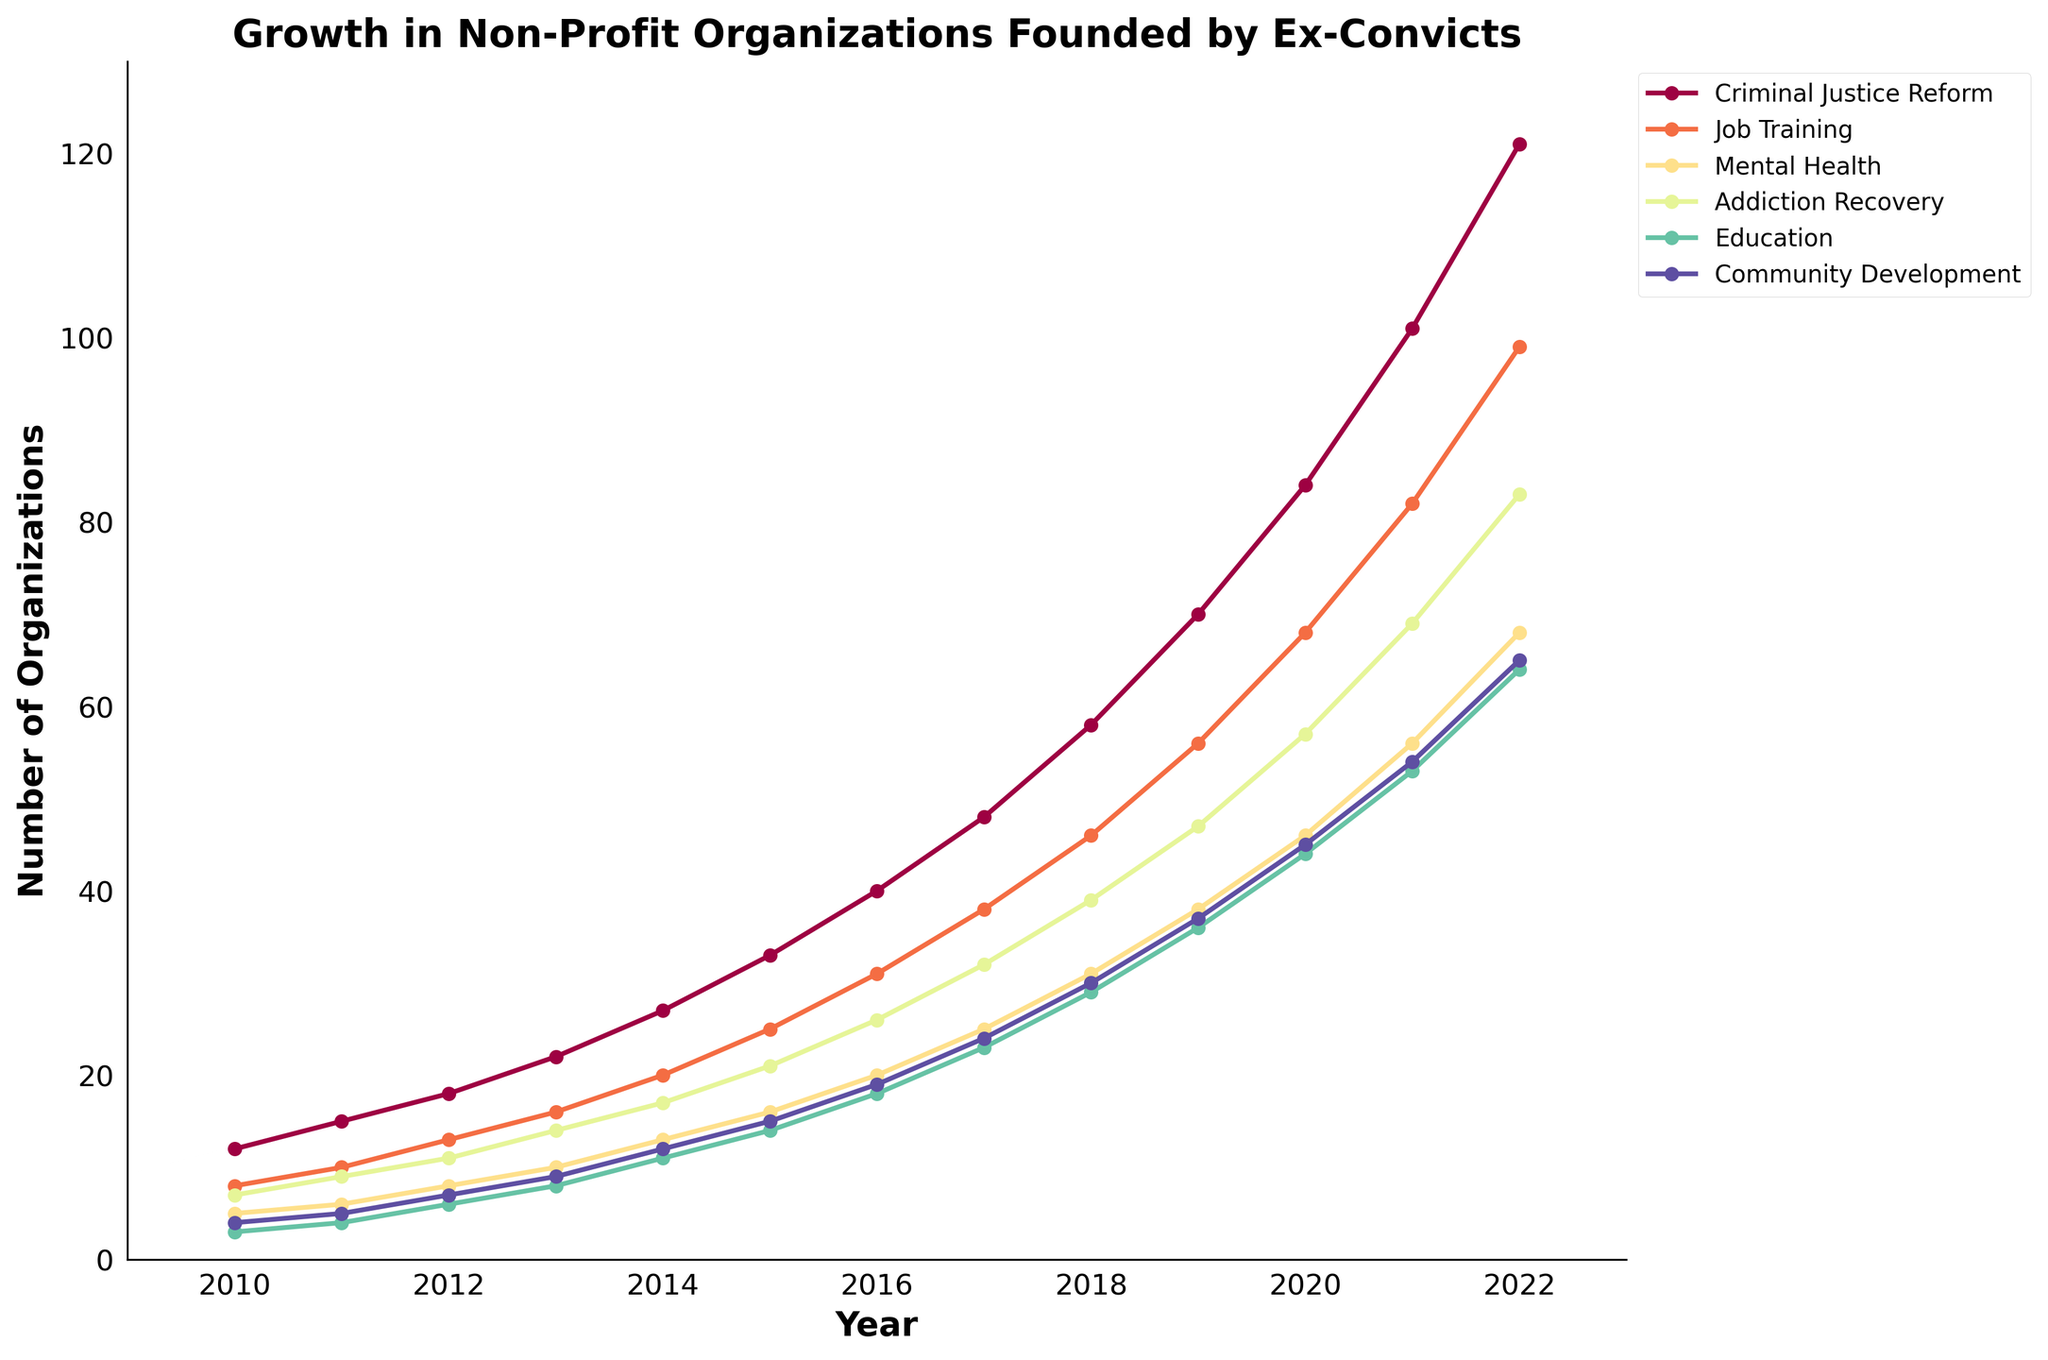Which organization focus area had the highest growth from 2010 to 2022? To determine this, examine the endpoints of each line in the chart. The line for 'Criminal Justice Reform' starts at 12 in 2010 and ends at 121 in 2022, which is the highest among all focus areas.
Answer: Criminal Justice Reform How many organizations in total were there for the three largest categories in 2022? Add the number of organizations for 'Criminal Justice Reform,' 'Job Training,' and 'Mental Health' in 2022. According to the chart: 121 (Criminal Justice Reform) + 99 (Job Training) + 68 (Mental Health) = 288.
Answer: 288 Which focus area had the least number of organizations in 2015, and what was the number? Observe the lines in 2015 and identify the lowest point. 'Education' had the least number of organizations with only 14.
Answer: Education, 14 What is the difference in the number of 'Addiction Recovery' organizations between 2013 and 2017? Look at the values for Addiction Recovery in 2013 and 2017. In 2013, it is 14, and in 2017, it is 32. The difference is 32 - 14 = 18.
Answer: 18 In which year did the 'Community Development' organizations first reach a number greater than 30? Identify the year where the 'Community Development' line crosses above 30. The year is 2018.
Answer: 2018 By how much did the number of 'Job Training' organizations increase from 2011 to 2020? Calculate the increase in the line for 'Job Training' from 2011 (10) to 2020 (68). 68 - 10 = 58.
Answer: 58 What is the average annual growth in the number of 'Mental Health' organizations from 2010 to 2022? Add the number of organizations in 2010 (5) and 2022 (68), compute the difference (68 - 5 = 63), then divide by the number of years (2022 - 2010 = 12). 63 / 12 ≈ 5.25.
Answer: Approximately 5.25 Which two focus areas had the closest number of organizations in 2014, and what were those numbers? Identify and compare the 2014 points for each focus area. 'Mental Health' (13) and 'Addiction Recovery' (17) are the closest.
Answer: Mental Health (13) and Addiction Recovery (17) What was the combined total of 'Education' and 'Community Development' organizations in 2019? Sum the 2019 values for Education (36) and Community Development (37). 36 + 37 = 73.
Answer: 73 